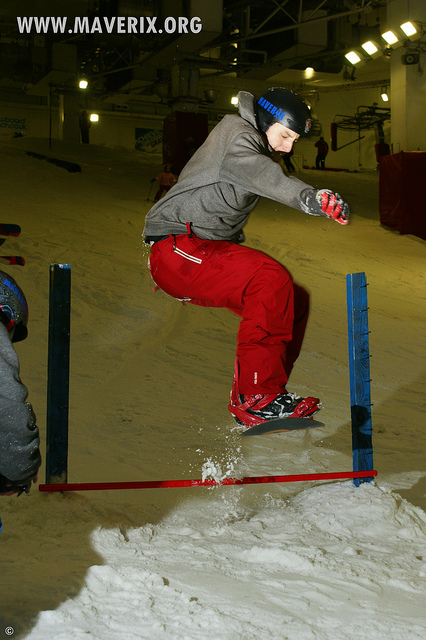Please extract the text content from this image. WWW.MAVERIX.ORG AVEB 